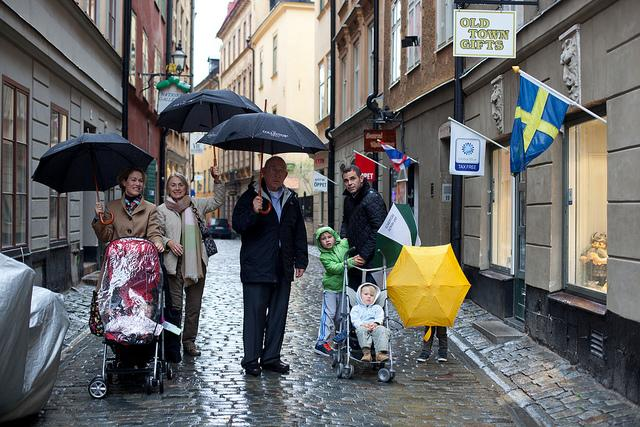What kind of flag is the blue and yellow one? sweden 